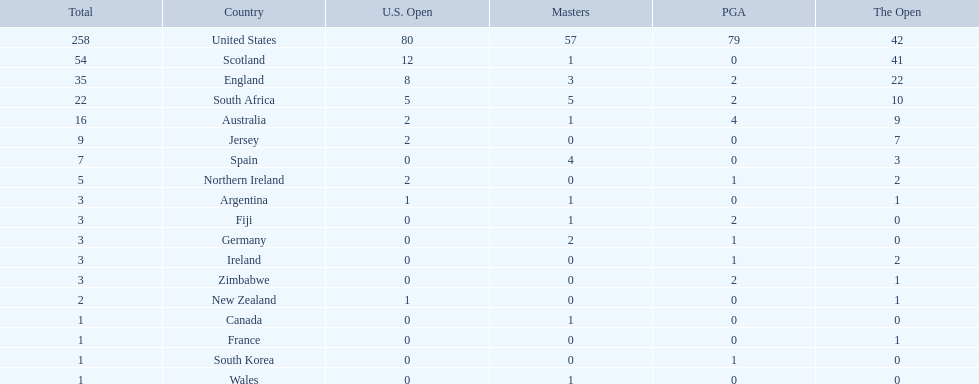What are all the countries? United States, Scotland, England, South Africa, Australia, Jersey, Spain, Northern Ireland, Argentina, Fiji, Germany, Ireland, Zimbabwe, New Zealand, Canada, France, South Korea, Wales. Which ones are located in africa? South Africa, Zimbabwe. Of those, which has the least champion golfers? Zimbabwe. 